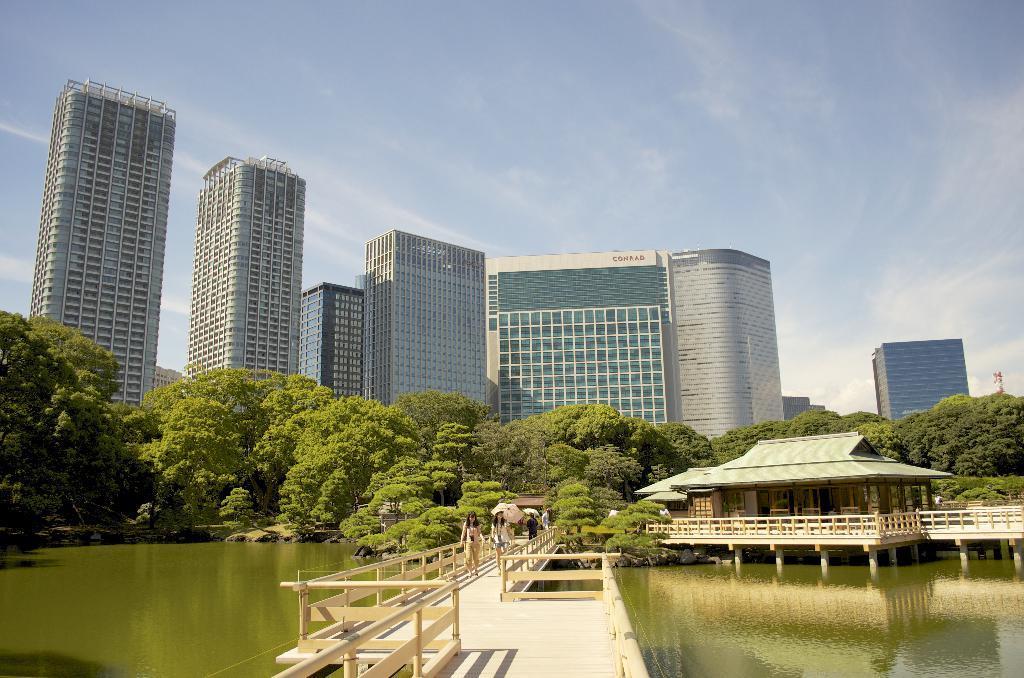Please provide a concise description of this image. In this image, in the middle we can see a bridge, there are some people walking on the bridge. We can see water, there are some buildings, trees and at the top we can see the sky. 